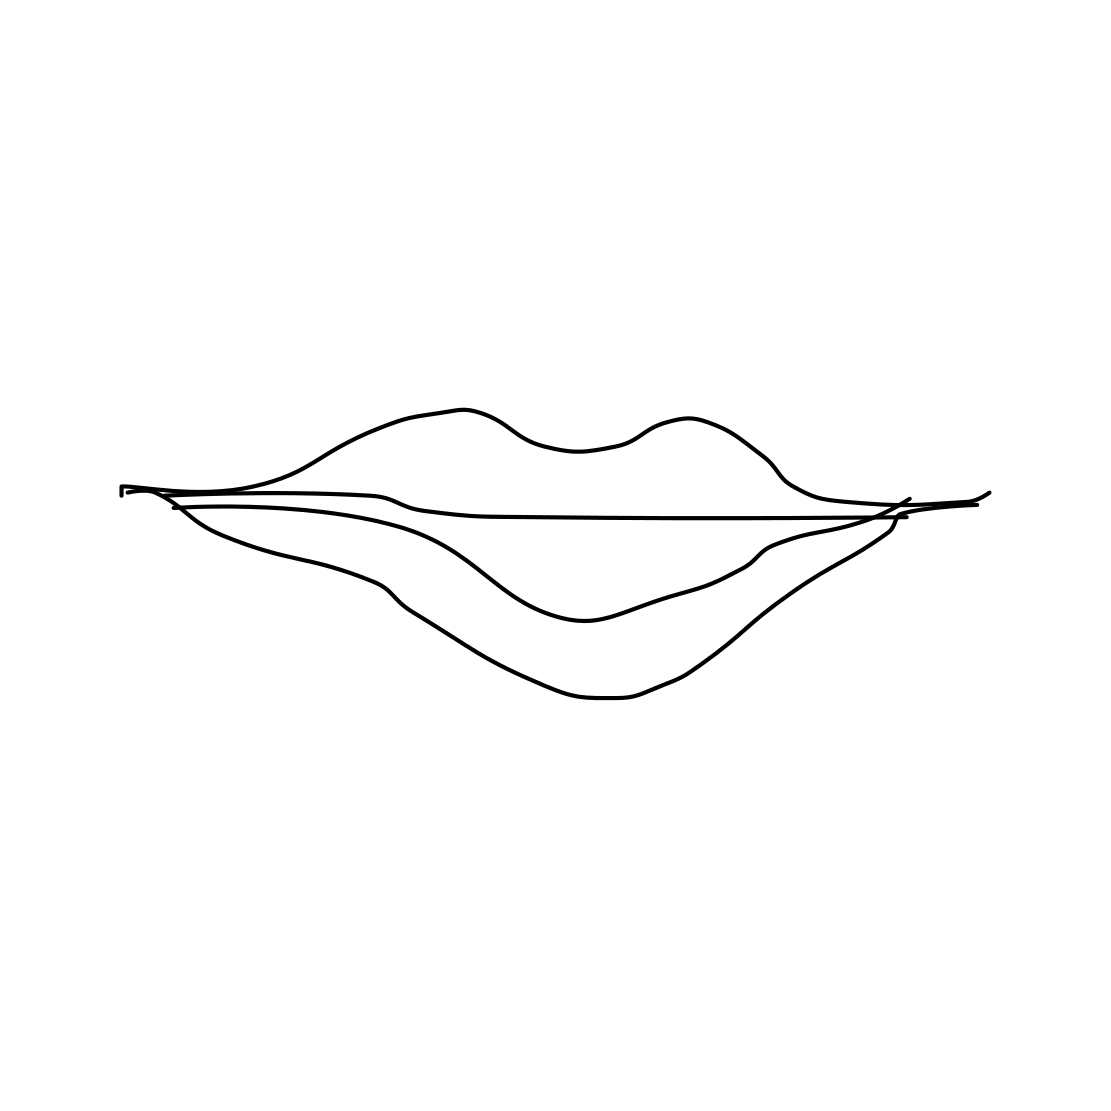Is there a sketchy present in the picture? No 